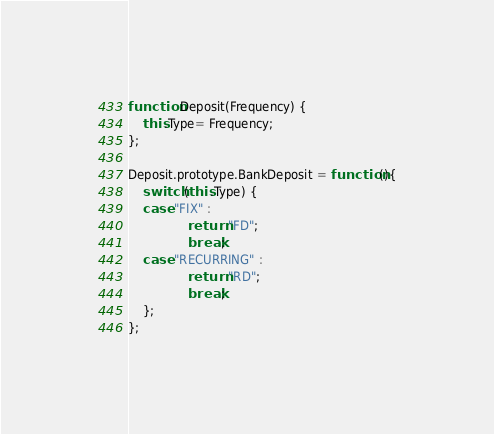Convert code to text. <code><loc_0><loc_0><loc_500><loc_500><_JavaScript_>function Deposit(Frequency) {
	this.Type= Frequency;
};

Deposit.prototype.BankDeposit = function(){
	switch (this.Type) {
	case "FIX" :	
				return "FD";
				break;
	case "RECURRING" :	
				return "RD";
				break;
	};
};</code> 